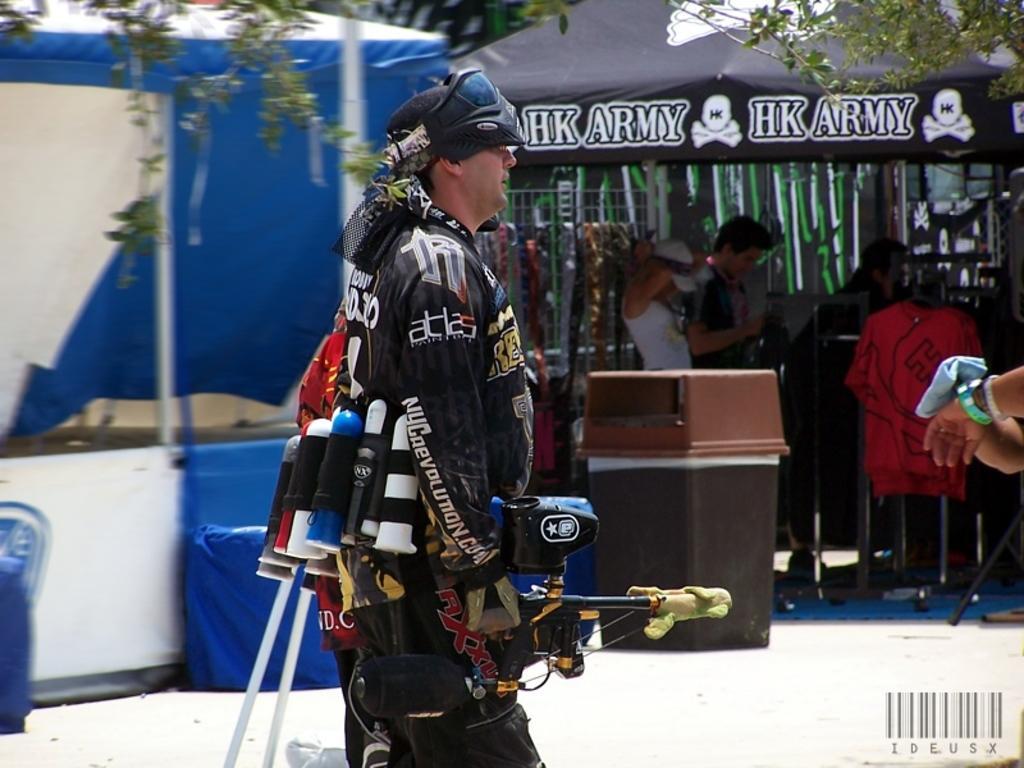Please provide a concise description of this image. There is a person in the center of the image, it seems like a gun in his hand, there are some other items behind him, there are stalls, people, trees, text and trash bin in the background area. 